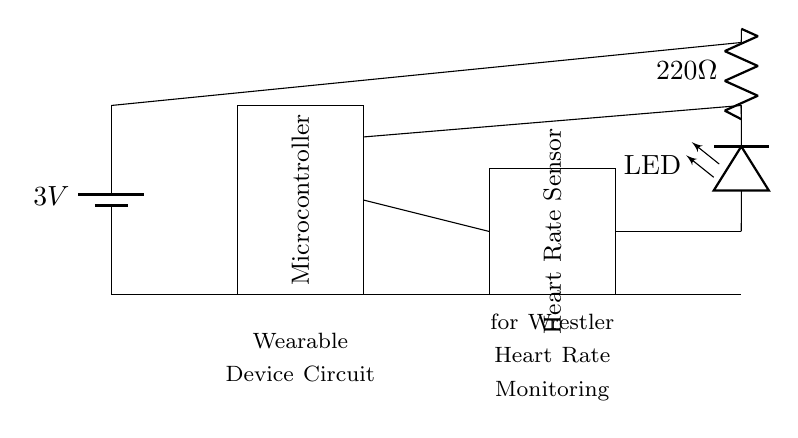What is the voltage of the power source? The circuit diagram shows a battery labeled with the voltage of 3V. This specifies the potential difference supplied to the circuit.
Answer: 3V What component measures heart rate? The circuit diagram has a rectangle labeled "Heart Rate Sensor," indicating that this component is responsible for measuring the heart rate.
Answer: Heart Rate Sensor What is the resistance value connected to the LED? The circuit indicates a resistor connected to the LED labeled with a value of 220 ohms, which dictates how much current flows through the LED.
Answer: 220 ohms Which component is used for displaying visual signals? The diagram includes an LED labeled as "LED" which is used to visually indicate the heart rate or its status through light emission.
Answer: LED Describe the connection between the microcontroller and the heart rate sensor. The circuit shows a direct connection (a line) between the microcontroller and the heart rate sensor, indicating they interact for data processing.
Answer: Direct connection What happens to the LED when the heart rate sensor is activated? The LED will light up when the heart rate sensor detects a heartbeat, showing real-time heart rate status. This is contingent on the appropriate current flow through the LED via the microcontroller controlling it.
Answer: LED lights up 